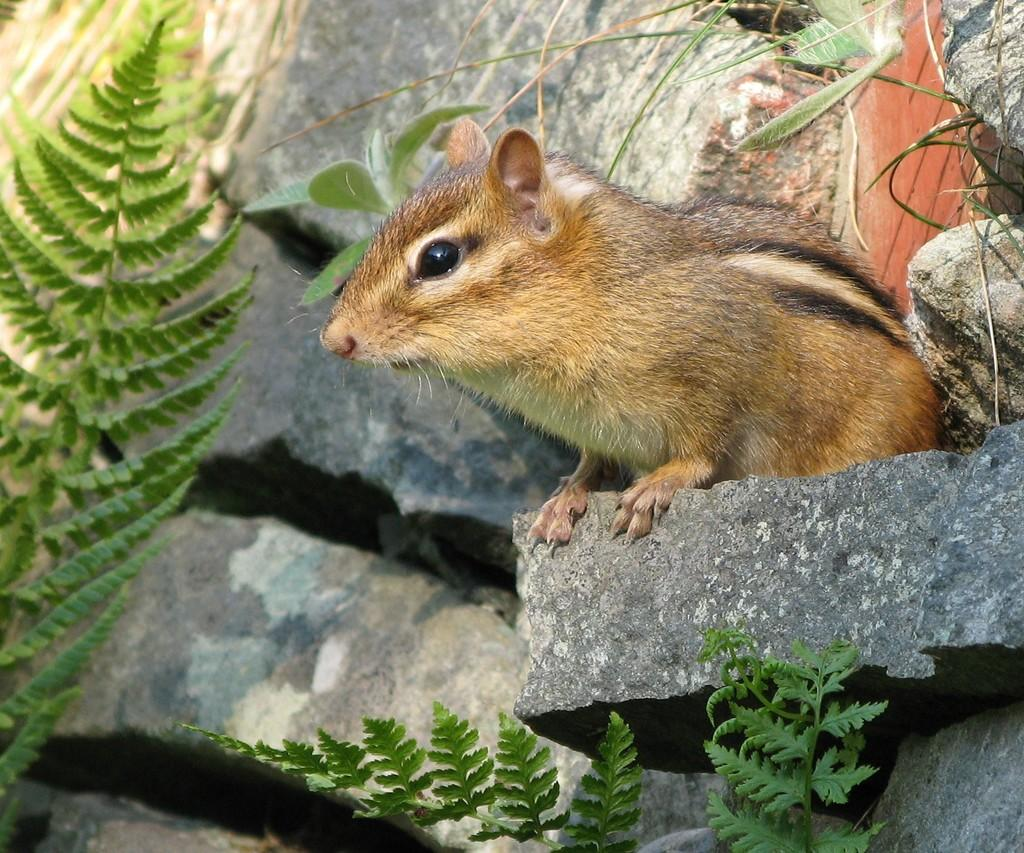What animal can be seen in the image? There is a mouse on a stone in the image. What type of vegetation is present in the image? There are plants in the image. What type of geological features are visible in the image? There are rocks in the image. Can you determine the time of day when the image was taken? The image was likely taken during the day, as there is sufficient light to see the details clearly. What type of tub is visible in the image? There is no tub present in the image. What knowledge does the mouse possess about the plants in the image? The image does not provide any information about the mouse's knowledge of the plants. 